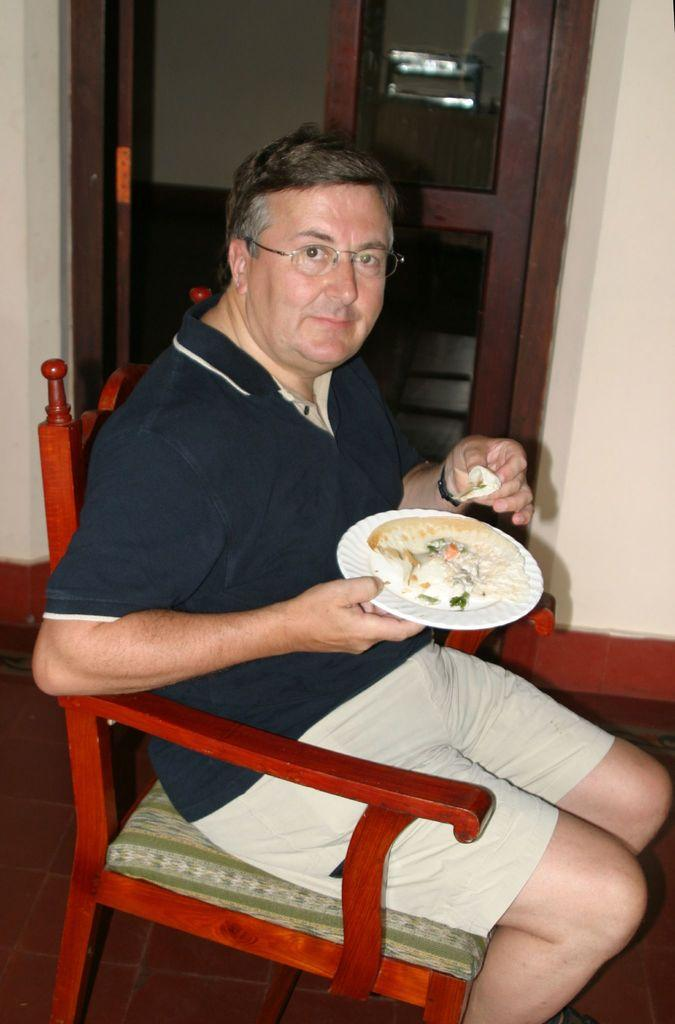Who is present in the image? There is a man in the image. What is the man wearing? The man is wearing spectacles. What is the man holding in his hand? The man is holding a plate with food in his hand. What is the man's posture in the image? The man is sitting on a chair. What is the man's facial expression in the image? The man is smiling. What can be seen in the background of the image? There is a door and a wall in the background of the image. How does the man's grip on the plate affect his nerve in the image? There is no information about the man's grip on the plate or its effect on his nerve in the image. 